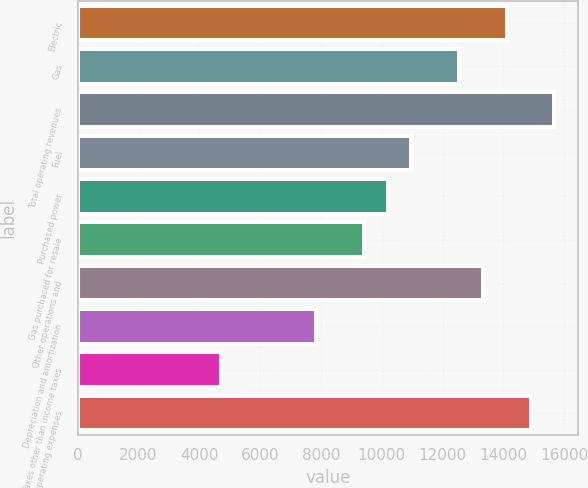Convert chart to OTSL. <chart><loc_0><loc_0><loc_500><loc_500><bar_chart><fcel>Electric<fcel>Gas<fcel>Total operating revenues<fcel>Fuel<fcel>Purchased power<fcel>Gas purchased for resale<fcel>Other operations and<fcel>Depreciation and amortization<fcel>Taxes other than income taxes<fcel>Total operating expenses<nl><fcel>14107.9<fcel>12540.6<fcel>15675.1<fcel>10973.4<fcel>10189.8<fcel>9406.2<fcel>13324.2<fcel>7838.98<fcel>4704.54<fcel>14891.5<nl></chart> 